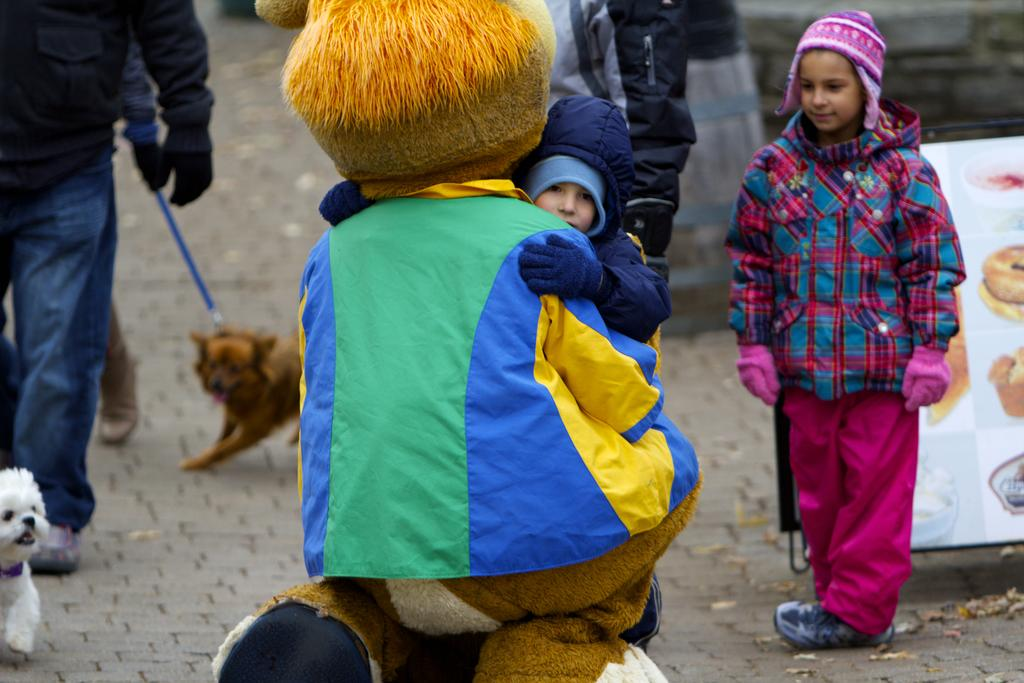What can be seen on the path in the image? There are people and kids on the path in the image. How many dogs are present in the image? There are two dogs in the image. What is the purpose of the banner in the image? The purpose of the banner in the image is not specified, but it could be for an event or celebration. What are some of the various objects visible in the image? Some of the various objects visible in the image include the banner, the dogs, and the people and kids on the path. What is the interaction between the kid and the person wearing a costume in the image? A kid is hugging a person wearing a costume in the image. What type of brain is visible in the image? There is no brain visible in the image. Is there a fan in the image? There is no fan present in the image. 